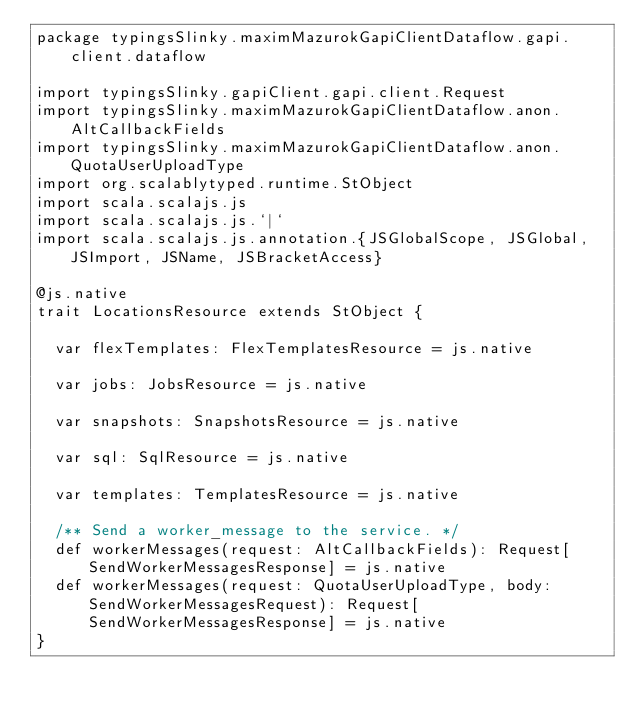Convert code to text. <code><loc_0><loc_0><loc_500><loc_500><_Scala_>package typingsSlinky.maximMazurokGapiClientDataflow.gapi.client.dataflow

import typingsSlinky.gapiClient.gapi.client.Request
import typingsSlinky.maximMazurokGapiClientDataflow.anon.AltCallbackFields
import typingsSlinky.maximMazurokGapiClientDataflow.anon.QuotaUserUploadType
import org.scalablytyped.runtime.StObject
import scala.scalajs.js
import scala.scalajs.js.`|`
import scala.scalajs.js.annotation.{JSGlobalScope, JSGlobal, JSImport, JSName, JSBracketAccess}

@js.native
trait LocationsResource extends StObject {
  
  var flexTemplates: FlexTemplatesResource = js.native
  
  var jobs: JobsResource = js.native
  
  var snapshots: SnapshotsResource = js.native
  
  var sql: SqlResource = js.native
  
  var templates: TemplatesResource = js.native
  
  /** Send a worker_message to the service. */
  def workerMessages(request: AltCallbackFields): Request[SendWorkerMessagesResponse] = js.native
  def workerMessages(request: QuotaUserUploadType, body: SendWorkerMessagesRequest): Request[SendWorkerMessagesResponse] = js.native
}
</code> 